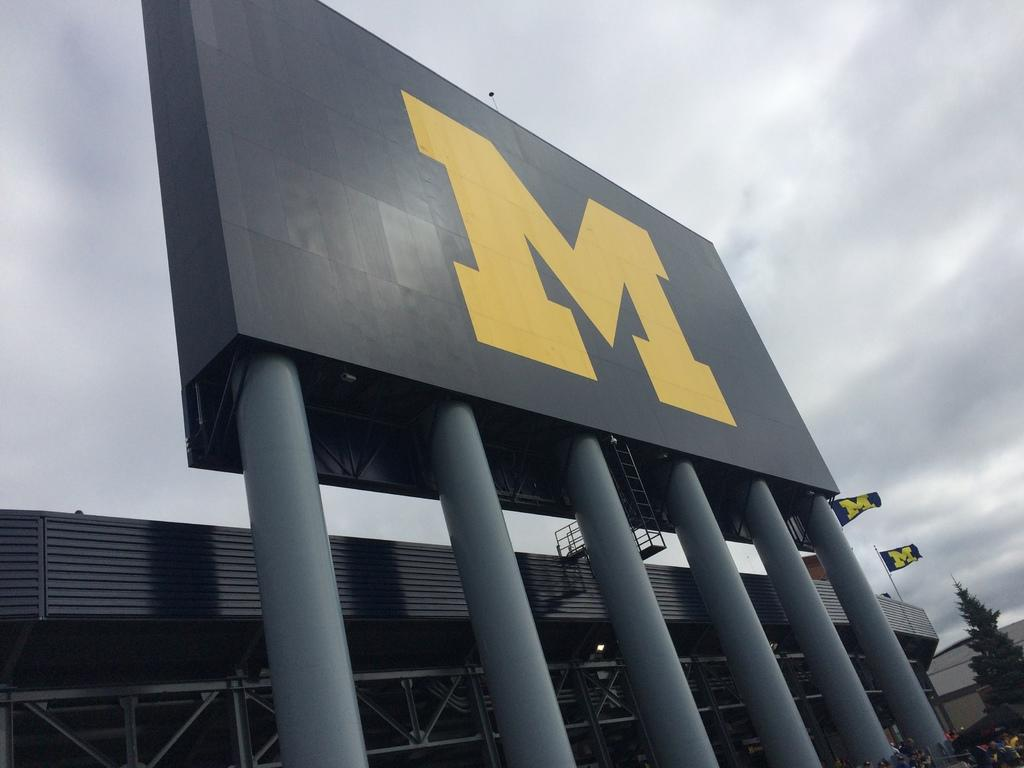What is the main structure visible in the image? There is a hoarding in the image. What type of vegetation can be seen on the right side of the image? There is a tree on the right side of the image. How many flags are present in the image? There are two flags in the image. What is visible at the top of the image? The sky is visible at the top of the image. Can you see any corn growing in the field in the image? There is no field or corn present in the image. Are there any creatures with fangs visible in the image? There are no creatures with fangs present in the image. 